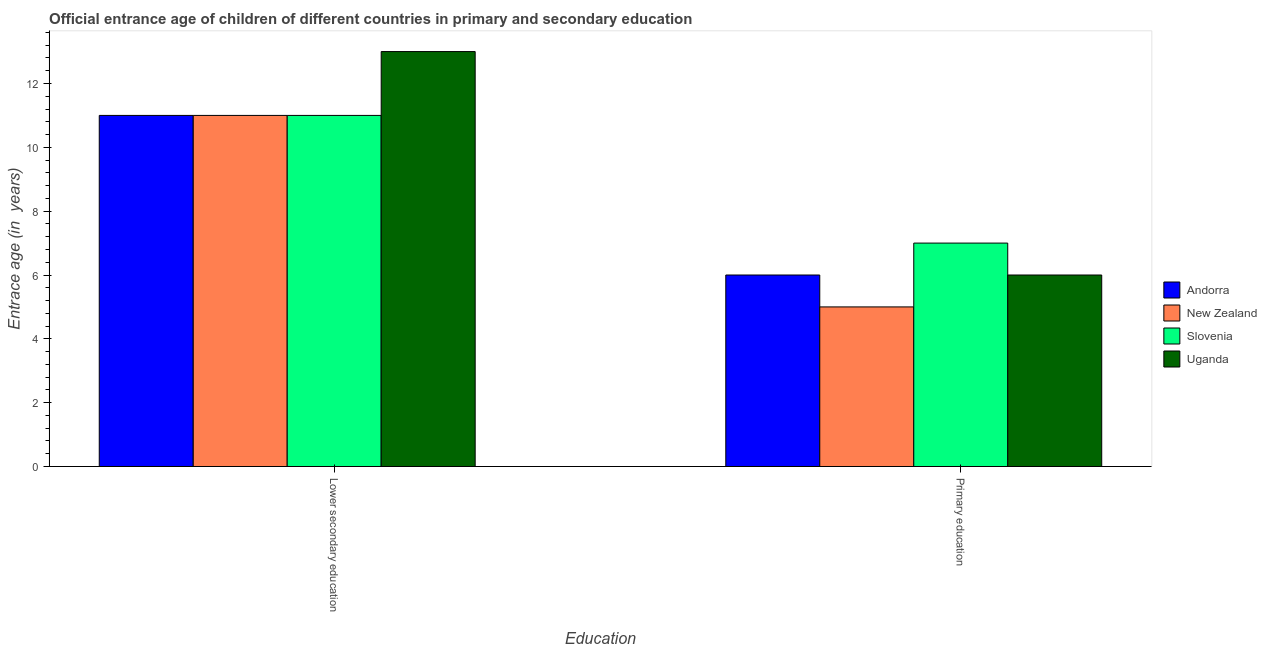Are the number of bars per tick equal to the number of legend labels?
Keep it short and to the point. Yes. How many bars are there on the 1st tick from the left?
Offer a terse response. 4. How many bars are there on the 1st tick from the right?
Your answer should be compact. 4. What is the entrance age of children in lower secondary education in New Zealand?
Give a very brief answer. 11. Across all countries, what is the maximum entrance age of chiildren in primary education?
Provide a succinct answer. 7. Across all countries, what is the minimum entrance age of children in lower secondary education?
Ensure brevity in your answer.  11. In which country was the entrance age of children in lower secondary education maximum?
Offer a terse response. Uganda. In which country was the entrance age of children in lower secondary education minimum?
Your response must be concise. Andorra. What is the total entrance age of children in lower secondary education in the graph?
Your response must be concise. 46. What is the difference between the entrance age of chiildren in primary education in Andorra and that in New Zealand?
Keep it short and to the point. 1. What is the difference between the entrance age of chiildren in primary education in Slovenia and the entrance age of children in lower secondary education in Uganda?
Make the answer very short. -6. What is the difference between the entrance age of chiildren in primary education and entrance age of children in lower secondary education in Slovenia?
Ensure brevity in your answer.  -4. In how many countries, is the entrance age of chiildren in primary education greater than 9.6 years?
Keep it short and to the point. 0. What is the ratio of the entrance age of children in lower secondary education in Uganda to that in New Zealand?
Your answer should be compact. 1.18. What does the 4th bar from the left in Primary education represents?
Keep it short and to the point. Uganda. What does the 1st bar from the right in Primary education represents?
Provide a short and direct response. Uganda. How many bars are there?
Provide a succinct answer. 8. Are all the bars in the graph horizontal?
Make the answer very short. No. What is the difference between two consecutive major ticks on the Y-axis?
Your answer should be very brief. 2. Are the values on the major ticks of Y-axis written in scientific E-notation?
Your response must be concise. No. Does the graph contain any zero values?
Your answer should be very brief. No. How many legend labels are there?
Provide a succinct answer. 4. How are the legend labels stacked?
Provide a succinct answer. Vertical. What is the title of the graph?
Your response must be concise. Official entrance age of children of different countries in primary and secondary education. What is the label or title of the X-axis?
Make the answer very short. Education. What is the label or title of the Y-axis?
Offer a terse response. Entrace age (in  years). What is the Entrace age (in  years) in New Zealand in Lower secondary education?
Your answer should be very brief. 11. What is the Entrace age (in  years) of New Zealand in Primary education?
Provide a short and direct response. 5. What is the Entrace age (in  years) in Uganda in Primary education?
Your answer should be very brief. 6. Across all Education, what is the maximum Entrace age (in  years) of Andorra?
Keep it short and to the point. 11. Across all Education, what is the maximum Entrace age (in  years) in Slovenia?
Give a very brief answer. 11. Across all Education, what is the maximum Entrace age (in  years) in Uganda?
Ensure brevity in your answer.  13. Across all Education, what is the minimum Entrace age (in  years) in Slovenia?
Provide a succinct answer. 7. Across all Education, what is the minimum Entrace age (in  years) of Uganda?
Offer a very short reply. 6. What is the difference between the Entrace age (in  years) of New Zealand in Lower secondary education and that in Primary education?
Your response must be concise. 6. What is the difference between the Entrace age (in  years) in Slovenia in Lower secondary education and that in Primary education?
Your answer should be very brief. 4. What is the difference between the Entrace age (in  years) of Uganda in Lower secondary education and that in Primary education?
Offer a terse response. 7. What is the difference between the Entrace age (in  years) in Andorra in Lower secondary education and the Entrace age (in  years) in New Zealand in Primary education?
Your answer should be compact. 6. What is the difference between the Entrace age (in  years) of New Zealand in Lower secondary education and the Entrace age (in  years) of Slovenia in Primary education?
Offer a very short reply. 4. What is the average Entrace age (in  years) of New Zealand per Education?
Your answer should be compact. 8. What is the difference between the Entrace age (in  years) in Andorra and Entrace age (in  years) in Slovenia in Lower secondary education?
Provide a short and direct response. 0. What is the difference between the Entrace age (in  years) in Andorra and Entrace age (in  years) in Uganda in Lower secondary education?
Provide a short and direct response. -2. What is the difference between the Entrace age (in  years) in New Zealand and Entrace age (in  years) in Uganda in Lower secondary education?
Your answer should be compact. -2. What is the difference between the Entrace age (in  years) of Andorra and Entrace age (in  years) of New Zealand in Primary education?
Provide a succinct answer. 1. What is the difference between the Entrace age (in  years) of Andorra and Entrace age (in  years) of Slovenia in Primary education?
Ensure brevity in your answer.  -1. What is the difference between the Entrace age (in  years) of New Zealand and Entrace age (in  years) of Slovenia in Primary education?
Offer a terse response. -2. What is the difference between the Entrace age (in  years) in Slovenia and Entrace age (in  years) in Uganda in Primary education?
Provide a short and direct response. 1. What is the ratio of the Entrace age (in  years) of Andorra in Lower secondary education to that in Primary education?
Ensure brevity in your answer.  1.83. What is the ratio of the Entrace age (in  years) of Slovenia in Lower secondary education to that in Primary education?
Offer a very short reply. 1.57. What is the ratio of the Entrace age (in  years) in Uganda in Lower secondary education to that in Primary education?
Your response must be concise. 2.17. What is the difference between the highest and the second highest Entrace age (in  years) of Andorra?
Offer a terse response. 5. What is the difference between the highest and the second highest Entrace age (in  years) of New Zealand?
Your answer should be very brief. 6. What is the difference between the highest and the second highest Entrace age (in  years) in Slovenia?
Your response must be concise. 4. What is the difference between the highest and the second highest Entrace age (in  years) of Uganda?
Your answer should be compact. 7. What is the difference between the highest and the lowest Entrace age (in  years) of Andorra?
Give a very brief answer. 5. What is the difference between the highest and the lowest Entrace age (in  years) in New Zealand?
Provide a succinct answer. 6. What is the difference between the highest and the lowest Entrace age (in  years) in Uganda?
Offer a terse response. 7. 